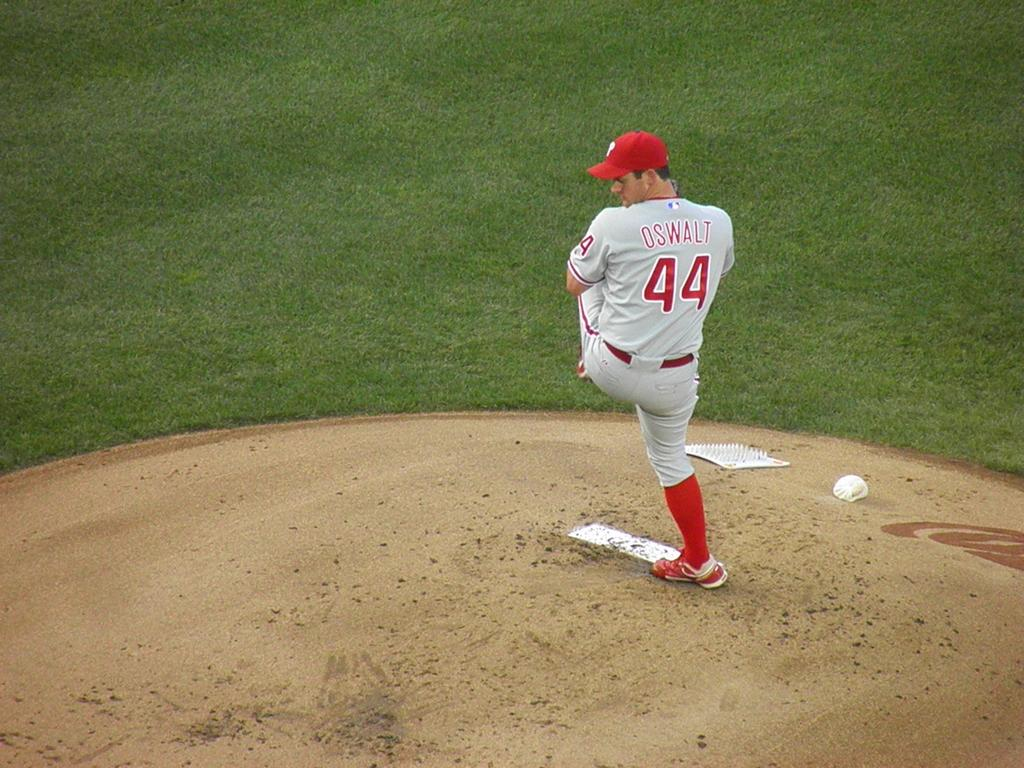Provide a one-sentence caption for the provided image. A man in a baseball uniform with the number 44 on the back. 